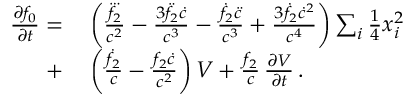<formula> <loc_0><loc_0><loc_500><loc_500>\begin{array} { r l } { \frac { \partial f _ { 0 } } { \partial t } = } & \left ( \frac { \dddot { f _ { 2 } } } { c ^ { 2 } } - \frac { 3 \ddot { f } _ { 2 } \dot { c } } { c ^ { 3 } } - \frac { \dot { f } _ { 2 } \ddot { c } } { c ^ { 3 } } + \frac { 3 \dot { f } _ { 2 } \dot { c } ^ { 2 } } { c ^ { 4 } } \right ) \sum _ { i } { \frac { 1 } { 4 } } x _ { i } ^ { 2 } } \\ { + } & \left ( \frac { \dot { f } _ { 2 } } { c } - \frac { f _ { 2 } \dot { c } } { c ^ { 2 } } \right ) V + \frac { f _ { 2 } } { c } \, \frac { \partial V } { \partial t } \, . } \end{array}</formula> 